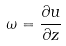Convert formula to latex. <formula><loc_0><loc_0><loc_500><loc_500>\omega = \frac { \partial u } { \partial z }</formula> 